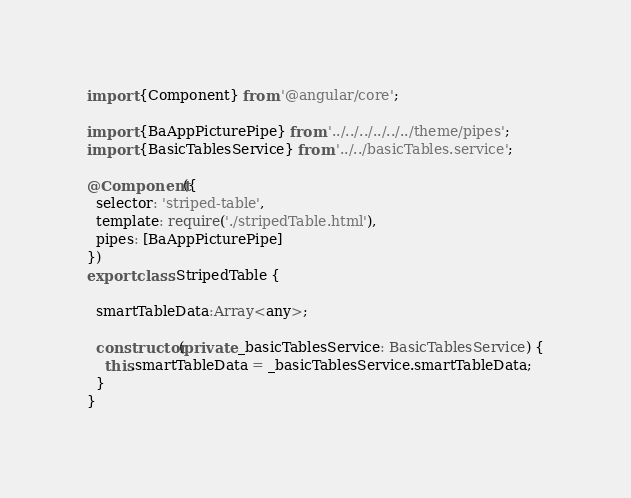<code> <loc_0><loc_0><loc_500><loc_500><_TypeScript_>import {Component} from '@angular/core';

import {BaAppPicturePipe} from '../../../../../../theme/pipes';
import {BasicTablesService} from '../../basicTables.service';

@Component({
  selector: 'striped-table',
  template: require('./stripedTable.html'),
  pipes: [BaAppPicturePipe]
})
export class StripedTable {

  smartTableData:Array<any>;

  constructor(private _basicTablesService: BasicTablesService) {
    this.smartTableData = _basicTablesService.smartTableData;
  }
}
</code> 